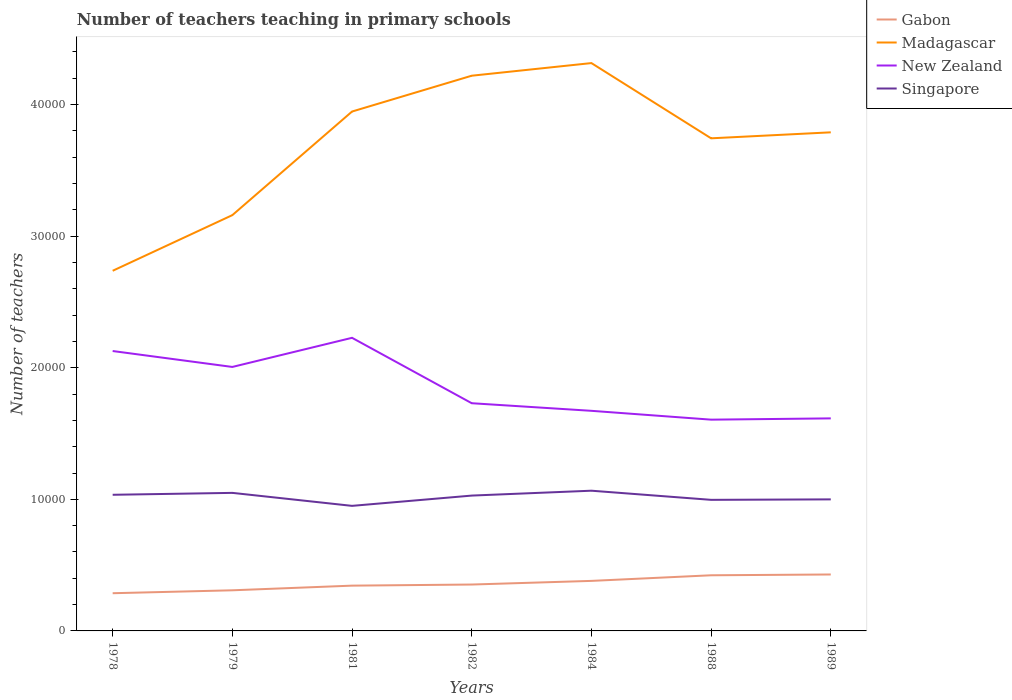Across all years, what is the maximum number of teachers teaching in primary schools in Madagascar?
Offer a very short reply. 2.74e+04. What is the total number of teachers teaching in primary schools in New Zealand in the graph?
Provide a succinct answer. -2214. What is the difference between the highest and the second highest number of teachers teaching in primary schools in Singapore?
Make the answer very short. 1152. What is the difference between the highest and the lowest number of teachers teaching in primary schools in Singapore?
Provide a succinct answer. 4. Is the number of teachers teaching in primary schools in Madagascar strictly greater than the number of teachers teaching in primary schools in New Zealand over the years?
Ensure brevity in your answer.  No. How many years are there in the graph?
Provide a succinct answer. 7. What is the difference between two consecutive major ticks on the Y-axis?
Provide a succinct answer. 10000. Does the graph contain any zero values?
Provide a short and direct response. No. Does the graph contain grids?
Give a very brief answer. No. What is the title of the graph?
Your answer should be very brief. Number of teachers teaching in primary schools. What is the label or title of the Y-axis?
Make the answer very short. Number of teachers. What is the Number of teachers of Gabon in 1978?
Provide a succinct answer. 2866. What is the Number of teachers of Madagascar in 1978?
Make the answer very short. 2.74e+04. What is the Number of teachers in New Zealand in 1978?
Keep it short and to the point. 2.13e+04. What is the Number of teachers of Singapore in 1978?
Give a very brief answer. 1.03e+04. What is the Number of teachers in Gabon in 1979?
Offer a terse response. 3088. What is the Number of teachers of Madagascar in 1979?
Ensure brevity in your answer.  3.16e+04. What is the Number of teachers of New Zealand in 1979?
Offer a very short reply. 2.01e+04. What is the Number of teachers in Singapore in 1979?
Provide a short and direct response. 1.05e+04. What is the Number of teachers in Gabon in 1981?
Provide a succinct answer. 3441. What is the Number of teachers in Madagascar in 1981?
Provide a succinct answer. 3.95e+04. What is the Number of teachers in New Zealand in 1981?
Your answer should be very brief. 2.23e+04. What is the Number of teachers of Singapore in 1981?
Your answer should be compact. 9505. What is the Number of teachers in Gabon in 1982?
Provide a succinct answer. 3526. What is the Number of teachers of Madagascar in 1982?
Make the answer very short. 4.22e+04. What is the Number of teachers in New Zealand in 1982?
Your answer should be compact. 1.73e+04. What is the Number of teachers of Singapore in 1982?
Your answer should be very brief. 1.03e+04. What is the Number of teachers of Gabon in 1984?
Your answer should be very brief. 3802. What is the Number of teachers in Madagascar in 1984?
Give a very brief answer. 4.32e+04. What is the Number of teachers in New Zealand in 1984?
Offer a very short reply. 1.67e+04. What is the Number of teachers in Singapore in 1984?
Provide a succinct answer. 1.07e+04. What is the Number of teachers of Gabon in 1988?
Provide a short and direct response. 4229. What is the Number of teachers in Madagascar in 1988?
Keep it short and to the point. 3.74e+04. What is the Number of teachers of New Zealand in 1988?
Make the answer very short. 1.61e+04. What is the Number of teachers in Singapore in 1988?
Ensure brevity in your answer.  9962. What is the Number of teachers in Gabon in 1989?
Give a very brief answer. 4289. What is the Number of teachers of Madagascar in 1989?
Provide a short and direct response. 3.79e+04. What is the Number of teachers of New Zealand in 1989?
Provide a short and direct response. 1.62e+04. What is the Number of teachers of Singapore in 1989?
Keep it short and to the point. 9998. Across all years, what is the maximum Number of teachers in Gabon?
Your answer should be very brief. 4289. Across all years, what is the maximum Number of teachers in Madagascar?
Provide a succinct answer. 4.32e+04. Across all years, what is the maximum Number of teachers of New Zealand?
Offer a terse response. 2.23e+04. Across all years, what is the maximum Number of teachers of Singapore?
Your response must be concise. 1.07e+04. Across all years, what is the minimum Number of teachers of Gabon?
Make the answer very short. 2866. Across all years, what is the minimum Number of teachers of Madagascar?
Your answer should be very brief. 2.74e+04. Across all years, what is the minimum Number of teachers in New Zealand?
Provide a short and direct response. 1.61e+04. Across all years, what is the minimum Number of teachers of Singapore?
Your answer should be very brief. 9505. What is the total Number of teachers in Gabon in the graph?
Your response must be concise. 2.52e+04. What is the total Number of teachers in Madagascar in the graph?
Make the answer very short. 2.59e+05. What is the total Number of teachers of New Zealand in the graph?
Ensure brevity in your answer.  1.30e+05. What is the total Number of teachers of Singapore in the graph?
Ensure brevity in your answer.  7.12e+04. What is the difference between the Number of teachers in Gabon in 1978 and that in 1979?
Ensure brevity in your answer.  -222. What is the difference between the Number of teachers of Madagascar in 1978 and that in 1979?
Ensure brevity in your answer.  -4230. What is the difference between the Number of teachers in New Zealand in 1978 and that in 1979?
Make the answer very short. 1210. What is the difference between the Number of teachers of Singapore in 1978 and that in 1979?
Ensure brevity in your answer.  -145. What is the difference between the Number of teachers of Gabon in 1978 and that in 1981?
Give a very brief answer. -575. What is the difference between the Number of teachers of Madagascar in 1978 and that in 1981?
Make the answer very short. -1.21e+04. What is the difference between the Number of teachers of New Zealand in 1978 and that in 1981?
Ensure brevity in your answer.  -1004. What is the difference between the Number of teachers in Singapore in 1978 and that in 1981?
Offer a terse response. 842. What is the difference between the Number of teachers of Gabon in 1978 and that in 1982?
Provide a succinct answer. -660. What is the difference between the Number of teachers in Madagascar in 1978 and that in 1982?
Ensure brevity in your answer.  -1.48e+04. What is the difference between the Number of teachers of New Zealand in 1978 and that in 1982?
Keep it short and to the point. 3967. What is the difference between the Number of teachers of Singapore in 1978 and that in 1982?
Your answer should be very brief. 61. What is the difference between the Number of teachers of Gabon in 1978 and that in 1984?
Provide a succinct answer. -936. What is the difference between the Number of teachers in Madagascar in 1978 and that in 1984?
Your answer should be compact. -1.58e+04. What is the difference between the Number of teachers of New Zealand in 1978 and that in 1984?
Your answer should be compact. 4545. What is the difference between the Number of teachers of Singapore in 1978 and that in 1984?
Give a very brief answer. -310. What is the difference between the Number of teachers of Gabon in 1978 and that in 1988?
Keep it short and to the point. -1363. What is the difference between the Number of teachers of Madagascar in 1978 and that in 1988?
Your answer should be very brief. -1.01e+04. What is the difference between the Number of teachers in New Zealand in 1978 and that in 1988?
Provide a short and direct response. 5216. What is the difference between the Number of teachers of Singapore in 1978 and that in 1988?
Your response must be concise. 385. What is the difference between the Number of teachers of Gabon in 1978 and that in 1989?
Your answer should be compact. -1423. What is the difference between the Number of teachers in Madagascar in 1978 and that in 1989?
Your answer should be compact. -1.05e+04. What is the difference between the Number of teachers of New Zealand in 1978 and that in 1989?
Ensure brevity in your answer.  5119. What is the difference between the Number of teachers of Singapore in 1978 and that in 1989?
Your answer should be compact. 349. What is the difference between the Number of teachers in Gabon in 1979 and that in 1981?
Ensure brevity in your answer.  -353. What is the difference between the Number of teachers of Madagascar in 1979 and that in 1981?
Provide a succinct answer. -7873. What is the difference between the Number of teachers of New Zealand in 1979 and that in 1981?
Your answer should be very brief. -2214. What is the difference between the Number of teachers of Singapore in 1979 and that in 1981?
Give a very brief answer. 987. What is the difference between the Number of teachers in Gabon in 1979 and that in 1982?
Your response must be concise. -438. What is the difference between the Number of teachers of Madagascar in 1979 and that in 1982?
Provide a short and direct response. -1.06e+04. What is the difference between the Number of teachers of New Zealand in 1979 and that in 1982?
Your answer should be very brief. 2757. What is the difference between the Number of teachers in Singapore in 1979 and that in 1982?
Make the answer very short. 206. What is the difference between the Number of teachers of Gabon in 1979 and that in 1984?
Provide a short and direct response. -714. What is the difference between the Number of teachers in Madagascar in 1979 and that in 1984?
Provide a short and direct response. -1.16e+04. What is the difference between the Number of teachers in New Zealand in 1979 and that in 1984?
Your answer should be compact. 3335. What is the difference between the Number of teachers of Singapore in 1979 and that in 1984?
Offer a very short reply. -165. What is the difference between the Number of teachers in Gabon in 1979 and that in 1988?
Your answer should be very brief. -1141. What is the difference between the Number of teachers of Madagascar in 1979 and that in 1988?
Keep it short and to the point. -5838. What is the difference between the Number of teachers of New Zealand in 1979 and that in 1988?
Offer a terse response. 4006. What is the difference between the Number of teachers in Singapore in 1979 and that in 1988?
Give a very brief answer. 530. What is the difference between the Number of teachers of Gabon in 1979 and that in 1989?
Provide a succinct answer. -1201. What is the difference between the Number of teachers in Madagascar in 1979 and that in 1989?
Provide a succinct answer. -6293. What is the difference between the Number of teachers of New Zealand in 1979 and that in 1989?
Ensure brevity in your answer.  3909. What is the difference between the Number of teachers in Singapore in 1979 and that in 1989?
Your answer should be very brief. 494. What is the difference between the Number of teachers of Gabon in 1981 and that in 1982?
Give a very brief answer. -85. What is the difference between the Number of teachers in Madagascar in 1981 and that in 1982?
Offer a terse response. -2723. What is the difference between the Number of teachers of New Zealand in 1981 and that in 1982?
Give a very brief answer. 4971. What is the difference between the Number of teachers in Singapore in 1981 and that in 1982?
Give a very brief answer. -781. What is the difference between the Number of teachers of Gabon in 1981 and that in 1984?
Your answer should be compact. -361. What is the difference between the Number of teachers in Madagascar in 1981 and that in 1984?
Make the answer very short. -3683. What is the difference between the Number of teachers in New Zealand in 1981 and that in 1984?
Offer a very short reply. 5549. What is the difference between the Number of teachers in Singapore in 1981 and that in 1984?
Offer a very short reply. -1152. What is the difference between the Number of teachers of Gabon in 1981 and that in 1988?
Keep it short and to the point. -788. What is the difference between the Number of teachers in Madagascar in 1981 and that in 1988?
Your response must be concise. 2035. What is the difference between the Number of teachers of New Zealand in 1981 and that in 1988?
Give a very brief answer. 6220. What is the difference between the Number of teachers in Singapore in 1981 and that in 1988?
Provide a short and direct response. -457. What is the difference between the Number of teachers of Gabon in 1981 and that in 1989?
Your response must be concise. -848. What is the difference between the Number of teachers in Madagascar in 1981 and that in 1989?
Offer a terse response. 1580. What is the difference between the Number of teachers in New Zealand in 1981 and that in 1989?
Your response must be concise. 6123. What is the difference between the Number of teachers in Singapore in 1981 and that in 1989?
Provide a succinct answer. -493. What is the difference between the Number of teachers of Gabon in 1982 and that in 1984?
Ensure brevity in your answer.  -276. What is the difference between the Number of teachers of Madagascar in 1982 and that in 1984?
Make the answer very short. -960. What is the difference between the Number of teachers in New Zealand in 1982 and that in 1984?
Offer a very short reply. 578. What is the difference between the Number of teachers in Singapore in 1982 and that in 1984?
Ensure brevity in your answer.  -371. What is the difference between the Number of teachers of Gabon in 1982 and that in 1988?
Ensure brevity in your answer.  -703. What is the difference between the Number of teachers in Madagascar in 1982 and that in 1988?
Provide a short and direct response. 4758. What is the difference between the Number of teachers in New Zealand in 1982 and that in 1988?
Offer a very short reply. 1249. What is the difference between the Number of teachers in Singapore in 1982 and that in 1988?
Make the answer very short. 324. What is the difference between the Number of teachers in Gabon in 1982 and that in 1989?
Provide a succinct answer. -763. What is the difference between the Number of teachers in Madagascar in 1982 and that in 1989?
Give a very brief answer. 4303. What is the difference between the Number of teachers in New Zealand in 1982 and that in 1989?
Ensure brevity in your answer.  1152. What is the difference between the Number of teachers of Singapore in 1982 and that in 1989?
Ensure brevity in your answer.  288. What is the difference between the Number of teachers in Gabon in 1984 and that in 1988?
Your response must be concise. -427. What is the difference between the Number of teachers in Madagascar in 1984 and that in 1988?
Keep it short and to the point. 5718. What is the difference between the Number of teachers of New Zealand in 1984 and that in 1988?
Your answer should be very brief. 671. What is the difference between the Number of teachers of Singapore in 1984 and that in 1988?
Offer a very short reply. 695. What is the difference between the Number of teachers of Gabon in 1984 and that in 1989?
Ensure brevity in your answer.  -487. What is the difference between the Number of teachers of Madagascar in 1984 and that in 1989?
Provide a short and direct response. 5263. What is the difference between the Number of teachers of New Zealand in 1984 and that in 1989?
Offer a terse response. 574. What is the difference between the Number of teachers in Singapore in 1984 and that in 1989?
Your response must be concise. 659. What is the difference between the Number of teachers in Gabon in 1988 and that in 1989?
Provide a succinct answer. -60. What is the difference between the Number of teachers of Madagascar in 1988 and that in 1989?
Keep it short and to the point. -455. What is the difference between the Number of teachers of New Zealand in 1988 and that in 1989?
Give a very brief answer. -97. What is the difference between the Number of teachers in Singapore in 1988 and that in 1989?
Your answer should be compact. -36. What is the difference between the Number of teachers of Gabon in 1978 and the Number of teachers of Madagascar in 1979?
Offer a very short reply. -2.87e+04. What is the difference between the Number of teachers in Gabon in 1978 and the Number of teachers in New Zealand in 1979?
Give a very brief answer. -1.72e+04. What is the difference between the Number of teachers of Gabon in 1978 and the Number of teachers of Singapore in 1979?
Your answer should be compact. -7626. What is the difference between the Number of teachers of Madagascar in 1978 and the Number of teachers of New Zealand in 1979?
Keep it short and to the point. 7308. What is the difference between the Number of teachers in Madagascar in 1978 and the Number of teachers in Singapore in 1979?
Offer a very short reply. 1.69e+04. What is the difference between the Number of teachers in New Zealand in 1978 and the Number of teachers in Singapore in 1979?
Give a very brief answer. 1.08e+04. What is the difference between the Number of teachers in Gabon in 1978 and the Number of teachers in Madagascar in 1981?
Provide a short and direct response. -3.66e+04. What is the difference between the Number of teachers in Gabon in 1978 and the Number of teachers in New Zealand in 1981?
Ensure brevity in your answer.  -1.94e+04. What is the difference between the Number of teachers in Gabon in 1978 and the Number of teachers in Singapore in 1981?
Give a very brief answer. -6639. What is the difference between the Number of teachers of Madagascar in 1978 and the Number of teachers of New Zealand in 1981?
Your answer should be compact. 5094. What is the difference between the Number of teachers in Madagascar in 1978 and the Number of teachers in Singapore in 1981?
Your answer should be very brief. 1.79e+04. What is the difference between the Number of teachers in New Zealand in 1978 and the Number of teachers in Singapore in 1981?
Your answer should be very brief. 1.18e+04. What is the difference between the Number of teachers in Gabon in 1978 and the Number of teachers in Madagascar in 1982?
Make the answer very short. -3.93e+04. What is the difference between the Number of teachers in Gabon in 1978 and the Number of teachers in New Zealand in 1982?
Your answer should be compact. -1.44e+04. What is the difference between the Number of teachers of Gabon in 1978 and the Number of teachers of Singapore in 1982?
Offer a terse response. -7420. What is the difference between the Number of teachers of Madagascar in 1978 and the Number of teachers of New Zealand in 1982?
Ensure brevity in your answer.  1.01e+04. What is the difference between the Number of teachers of Madagascar in 1978 and the Number of teachers of Singapore in 1982?
Make the answer very short. 1.71e+04. What is the difference between the Number of teachers of New Zealand in 1978 and the Number of teachers of Singapore in 1982?
Provide a succinct answer. 1.10e+04. What is the difference between the Number of teachers of Gabon in 1978 and the Number of teachers of Madagascar in 1984?
Offer a very short reply. -4.03e+04. What is the difference between the Number of teachers of Gabon in 1978 and the Number of teachers of New Zealand in 1984?
Your answer should be compact. -1.39e+04. What is the difference between the Number of teachers in Gabon in 1978 and the Number of teachers in Singapore in 1984?
Offer a terse response. -7791. What is the difference between the Number of teachers in Madagascar in 1978 and the Number of teachers in New Zealand in 1984?
Give a very brief answer. 1.06e+04. What is the difference between the Number of teachers of Madagascar in 1978 and the Number of teachers of Singapore in 1984?
Offer a terse response. 1.67e+04. What is the difference between the Number of teachers in New Zealand in 1978 and the Number of teachers in Singapore in 1984?
Ensure brevity in your answer.  1.06e+04. What is the difference between the Number of teachers of Gabon in 1978 and the Number of teachers of Madagascar in 1988?
Offer a very short reply. -3.46e+04. What is the difference between the Number of teachers of Gabon in 1978 and the Number of teachers of New Zealand in 1988?
Your response must be concise. -1.32e+04. What is the difference between the Number of teachers of Gabon in 1978 and the Number of teachers of Singapore in 1988?
Provide a succinct answer. -7096. What is the difference between the Number of teachers in Madagascar in 1978 and the Number of teachers in New Zealand in 1988?
Make the answer very short. 1.13e+04. What is the difference between the Number of teachers of Madagascar in 1978 and the Number of teachers of Singapore in 1988?
Ensure brevity in your answer.  1.74e+04. What is the difference between the Number of teachers in New Zealand in 1978 and the Number of teachers in Singapore in 1988?
Give a very brief answer. 1.13e+04. What is the difference between the Number of teachers in Gabon in 1978 and the Number of teachers in Madagascar in 1989?
Provide a short and direct response. -3.50e+04. What is the difference between the Number of teachers in Gabon in 1978 and the Number of teachers in New Zealand in 1989?
Your answer should be very brief. -1.33e+04. What is the difference between the Number of teachers in Gabon in 1978 and the Number of teachers in Singapore in 1989?
Ensure brevity in your answer.  -7132. What is the difference between the Number of teachers of Madagascar in 1978 and the Number of teachers of New Zealand in 1989?
Make the answer very short. 1.12e+04. What is the difference between the Number of teachers in Madagascar in 1978 and the Number of teachers in Singapore in 1989?
Your answer should be very brief. 1.74e+04. What is the difference between the Number of teachers in New Zealand in 1978 and the Number of teachers in Singapore in 1989?
Your answer should be very brief. 1.13e+04. What is the difference between the Number of teachers in Gabon in 1979 and the Number of teachers in Madagascar in 1981?
Make the answer very short. -3.64e+04. What is the difference between the Number of teachers in Gabon in 1979 and the Number of teachers in New Zealand in 1981?
Ensure brevity in your answer.  -1.92e+04. What is the difference between the Number of teachers of Gabon in 1979 and the Number of teachers of Singapore in 1981?
Provide a short and direct response. -6417. What is the difference between the Number of teachers of Madagascar in 1979 and the Number of teachers of New Zealand in 1981?
Provide a short and direct response. 9324. What is the difference between the Number of teachers in Madagascar in 1979 and the Number of teachers in Singapore in 1981?
Your answer should be very brief. 2.21e+04. What is the difference between the Number of teachers in New Zealand in 1979 and the Number of teachers in Singapore in 1981?
Ensure brevity in your answer.  1.06e+04. What is the difference between the Number of teachers of Gabon in 1979 and the Number of teachers of Madagascar in 1982?
Offer a very short reply. -3.91e+04. What is the difference between the Number of teachers in Gabon in 1979 and the Number of teachers in New Zealand in 1982?
Make the answer very short. -1.42e+04. What is the difference between the Number of teachers in Gabon in 1979 and the Number of teachers in Singapore in 1982?
Provide a short and direct response. -7198. What is the difference between the Number of teachers of Madagascar in 1979 and the Number of teachers of New Zealand in 1982?
Offer a very short reply. 1.43e+04. What is the difference between the Number of teachers in Madagascar in 1979 and the Number of teachers in Singapore in 1982?
Your answer should be very brief. 2.13e+04. What is the difference between the Number of teachers in New Zealand in 1979 and the Number of teachers in Singapore in 1982?
Make the answer very short. 9777. What is the difference between the Number of teachers of Gabon in 1979 and the Number of teachers of Madagascar in 1984?
Your response must be concise. -4.01e+04. What is the difference between the Number of teachers of Gabon in 1979 and the Number of teachers of New Zealand in 1984?
Keep it short and to the point. -1.36e+04. What is the difference between the Number of teachers in Gabon in 1979 and the Number of teachers in Singapore in 1984?
Provide a succinct answer. -7569. What is the difference between the Number of teachers of Madagascar in 1979 and the Number of teachers of New Zealand in 1984?
Ensure brevity in your answer.  1.49e+04. What is the difference between the Number of teachers of Madagascar in 1979 and the Number of teachers of Singapore in 1984?
Your response must be concise. 2.09e+04. What is the difference between the Number of teachers of New Zealand in 1979 and the Number of teachers of Singapore in 1984?
Your response must be concise. 9406. What is the difference between the Number of teachers of Gabon in 1979 and the Number of teachers of Madagascar in 1988?
Offer a very short reply. -3.44e+04. What is the difference between the Number of teachers in Gabon in 1979 and the Number of teachers in New Zealand in 1988?
Make the answer very short. -1.30e+04. What is the difference between the Number of teachers in Gabon in 1979 and the Number of teachers in Singapore in 1988?
Your response must be concise. -6874. What is the difference between the Number of teachers in Madagascar in 1979 and the Number of teachers in New Zealand in 1988?
Your answer should be very brief. 1.55e+04. What is the difference between the Number of teachers in Madagascar in 1979 and the Number of teachers in Singapore in 1988?
Your answer should be very brief. 2.16e+04. What is the difference between the Number of teachers of New Zealand in 1979 and the Number of teachers of Singapore in 1988?
Give a very brief answer. 1.01e+04. What is the difference between the Number of teachers in Gabon in 1979 and the Number of teachers in Madagascar in 1989?
Offer a very short reply. -3.48e+04. What is the difference between the Number of teachers of Gabon in 1979 and the Number of teachers of New Zealand in 1989?
Your response must be concise. -1.31e+04. What is the difference between the Number of teachers in Gabon in 1979 and the Number of teachers in Singapore in 1989?
Provide a short and direct response. -6910. What is the difference between the Number of teachers in Madagascar in 1979 and the Number of teachers in New Zealand in 1989?
Your answer should be very brief. 1.54e+04. What is the difference between the Number of teachers of Madagascar in 1979 and the Number of teachers of Singapore in 1989?
Your answer should be compact. 2.16e+04. What is the difference between the Number of teachers in New Zealand in 1979 and the Number of teachers in Singapore in 1989?
Your answer should be very brief. 1.01e+04. What is the difference between the Number of teachers in Gabon in 1981 and the Number of teachers in Madagascar in 1982?
Ensure brevity in your answer.  -3.88e+04. What is the difference between the Number of teachers in Gabon in 1981 and the Number of teachers in New Zealand in 1982?
Ensure brevity in your answer.  -1.39e+04. What is the difference between the Number of teachers of Gabon in 1981 and the Number of teachers of Singapore in 1982?
Your answer should be very brief. -6845. What is the difference between the Number of teachers of Madagascar in 1981 and the Number of teachers of New Zealand in 1982?
Your response must be concise. 2.22e+04. What is the difference between the Number of teachers in Madagascar in 1981 and the Number of teachers in Singapore in 1982?
Ensure brevity in your answer.  2.92e+04. What is the difference between the Number of teachers of New Zealand in 1981 and the Number of teachers of Singapore in 1982?
Keep it short and to the point. 1.20e+04. What is the difference between the Number of teachers of Gabon in 1981 and the Number of teachers of Madagascar in 1984?
Provide a succinct answer. -3.97e+04. What is the difference between the Number of teachers of Gabon in 1981 and the Number of teachers of New Zealand in 1984?
Your answer should be compact. -1.33e+04. What is the difference between the Number of teachers of Gabon in 1981 and the Number of teachers of Singapore in 1984?
Provide a short and direct response. -7216. What is the difference between the Number of teachers of Madagascar in 1981 and the Number of teachers of New Zealand in 1984?
Provide a succinct answer. 2.27e+04. What is the difference between the Number of teachers of Madagascar in 1981 and the Number of teachers of Singapore in 1984?
Make the answer very short. 2.88e+04. What is the difference between the Number of teachers of New Zealand in 1981 and the Number of teachers of Singapore in 1984?
Make the answer very short. 1.16e+04. What is the difference between the Number of teachers in Gabon in 1981 and the Number of teachers in Madagascar in 1988?
Offer a terse response. -3.40e+04. What is the difference between the Number of teachers in Gabon in 1981 and the Number of teachers in New Zealand in 1988?
Your answer should be compact. -1.26e+04. What is the difference between the Number of teachers of Gabon in 1981 and the Number of teachers of Singapore in 1988?
Provide a short and direct response. -6521. What is the difference between the Number of teachers of Madagascar in 1981 and the Number of teachers of New Zealand in 1988?
Your answer should be compact. 2.34e+04. What is the difference between the Number of teachers of Madagascar in 1981 and the Number of teachers of Singapore in 1988?
Provide a succinct answer. 2.95e+04. What is the difference between the Number of teachers of New Zealand in 1981 and the Number of teachers of Singapore in 1988?
Your answer should be compact. 1.23e+04. What is the difference between the Number of teachers in Gabon in 1981 and the Number of teachers in Madagascar in 1989?
Provide a succinct answer. -3.45e+04. What is the difference between the Number of teachers in Gabon in 1981 and the Number of teachers in New Zealand in 1989?
Your answer should be compact. -1.27e+04. What is the difference between the Number of teachers in Gabon in 1981 and the Number of teachers in Singapore in 1989?
Provide a short and direct response. -6557. What is the difference between the Number of teachers of Madagascar in 1981 and the Number of teachers of New Zealand in 1989?
Ensure brevity in your answer.  2.33e+04. What is the difference between the Number of teachers in Madagascar in 1981 and the Number of teachers in Singapore in 1989?
Give a very brief answer. 2.95e+04. What is the difference between the Number of teachers in New Zealand in 1981 and the Number of teachers in Singapore in 1989?
Provide a succinct answer. 1.23e+04. What is the difference between the Number of teachers in Gabon in 1982 and the Number of teachers in Madagascar in 1984?
Provide a short and direct response. -3.96e+04. What is the difference between the Number of teachers in Gabon in 1982 and the Number of teachers in New Zealand in 1984?
Your answer should be very brief. -1.32e+04. What is the difference between the Number of teachers in Gabon in 1982 and the Number of teachers in Singapore in 1984?
Offer a very short reply. -7131. What is the difference between the Number of teachers of Madagascar in 1982 and the Number of teachers of New Zealand in 1984?
Your response must be concise. 2.55e+04. What is the difference between the Number of teachers in Madagascar in 1982 and the Number of teachers in Singapore in 1984?
Give a very brief answer. 3.15e+04. What is the difference between the Number of teachers of New Zealand in 1982 and the Number of teachers of Singapore in 1984?
Offer a terse response. 6649. What is the difference between the Number of teachers in Gabon in 1982 and the Number of teachers in Madagascar in 1988?
Keep it short and to the point. -3.39e+04. What is the difference between the Number of teachers in Gabon in 1982 and the Number of teachers in New Zealand in 1988?
Provide a succinct answer. -1.25e+04. What is the difference between the Number of teachers of Gabon in 1982 and the Number of teachers of Singapore in 1988?
Ensure brevity in your answer.  -6436. What is the difference between the Number of teachers of Madagascar in 1982 and the Number of teachers of New Zealand in 1988?
Offer a terse response. 2.61e+04. What is the difference between the Number of teachers in Madagascar in 1982 and the Number of teachers in Singapore in 1988?
Offer a very short reply. 3.22e+04. What is the difference between the Number of teachers in New Zealand in 1982 and the Number of teachers in Singapore in 1988?
Your answer should be very brief. 7344. What is the difference between the Number of teachers of Gabon in 1982 and the Number of teachers of Madagascar in 1989?
Make the answer very short. -3.44e+04. What is the difference between the Number of teachers of Gabon in 1982 and the Number of teachers of New Zealand in 1989?
Your answer should be compact. -1.26e+04. What is the difference between the Number of teachers in Gabon in 1982 and the Number of teachers in Singapore in 1989?
Ensure brevity in your answer.  -6472. What is the difference between the Number of teachers in Madagascar in 1982 and the Number of teachers in New Zealand in 1989?
Your response must be concise. 2.60e+04. What is the difference between the Number of teachers in Madagascar in 1982 and the Number of teachers in Singapore in 1989?
Your answer should be very brief. 3.22e+04. What is the difference between the Number of teachers in New Zealand in 1982 and the Number of teachers in Singapore in 1989?
Give a very brief answer. 7308. What is the difference between the Number of teachers of Gabon in 1984 and the Number of teachers of Madagascar in 1988?
Offer a very short reply. -3.36e+04. What is the difference between the Number of teachers of Gabon in 1984 and the Number of teachers of New Zealand in 1988?
Offer a terse response. -1.23e+04. What is the difference between the Number of teachers in Gabon in 1984 and the Number of teachers in Singapore in 1988?
Ensure brevity in your answer.  -6160. What is the difference between the Number of teachers of Madagascar in 1984 and the Number of teachers of New Zealand in 1988?
Your answer should be very brief. 2.71e+04. What is the difference between the Number of teachers of Madagascar in 1984 and the Number of teachers of Singapore in 1988?
Your answer should be very brief. 3.32e+04. What is the difference between the Number of teachers in New Zealand in 1984 and the Number of teachers in Singapore in 1988?
Provide a succinct answer. 6766. What is the difference between the Number of teachers in Gabon in 1984 and the Number of teachers in Madagascar in 1989?
Provide a succinct answer. -3.41e+04. What is the difference between the Number of teachers of Gabon in 1984 and the Number of teachers of New Zealand in 1989?
Keep it short and to the point. -1.24e+04. What is the difference between the Number of teachers of Gabon in 1984 and the Number of teachers of Singapore in 1989?
Make the answer very short. -6196. What is the difference between the Number of teachers of Madagascar in 1984 and the Number of teachers of New Zealand in 1989?
Your response must be concise. 2.70e+04. What is the difference between the Number of teachers of Madagascar in 1984 and the Number of teachers of Singapore in 1989?
Offer a terse response. 3.32e+04. What is the difference between the Number of teachers in New Zealand in 1984 and the Number of teachers in Singapore in 1989?
Your response must be concise. 6730. What is the difference between the Number of teachers of Gabon in 1988 and the Number of teachers of Madagascar in 1989?
Ensure brevity in your answer.  -3.37e+04. What is the difference between the Number of teachers in Gabon in 1988 and the Number of teachers in New Zealand in 1989?
Ensure brevity in your answer.  -1.19e+04. What is the difference between the Number of teachers in Gabon in 1988 and the Number of teachers in Singapore in 1989?
Keep it short and to the point. -5769. What is the difference between the Number of teachers of Madagascar in 1988 and the Number of teachers of New Zealand in 1989?
Ensure brevity in your answer.  2.13e+04. What is the difference between the Number of teachers in Madagascar in 1988 and the Number of teachers in Singapore in 1989?
Make the answer very short. 2.74e+04. What is the difference between the Number of teachers in New Zealand in 1988 and the Number of teachers in Singapore in 1989?
Your answer should be compact. 6059. What is the average Number of teachers in Gabon per year?
Make the answer very short. 3605.86. What is the average Number of teachers in Madagascar per year?
Keep it short and to the point. 3.70e+04. What is the average Number of teachers of New Zealand per year?
Your response must be concise. 1.86e+04. What is the average Number of teachers in Singapore per year?
Your response must be concise. 1.02e+04. In the year 1978, what is the difference between the Number of teachers in Gabon and Number of teachers in Madagascar?
Your answer should be compact. -2.45e+04. In the year 1978, what is the difference between the Number of teachers of Gabon and Number of teachers of New Zealand?
Your answer should be compact. -1.84e+04. In the year 1978, what is the difference between the Number of teachers in Gabon and Number of teachers in Singapore?
Offer a very short reply. -7481. In the year 1978, what is the difference between the Number of teachers of Madagascar and Number of teachers of New Zealand?
Provide a succinct answer. 6098. In the year 1978, what is the difference between the Number of teachers in Madagascar and Number of teachers in Singapore?
Offer a terse response. 1.70e+04. In the year 1978, what is the difference between the Number of teachers in New Zealand and Number of teachers in Singapore?
Keep it short and to the point. 1.09e+04. In the year 1979, what is the difference between the Number of teachers of Gabon and Number of teachers of Madagascar?
Ensure brevity in your answer.  -2.85e+04. In the year 1979, what is the difference between the Number of teachers in Gabon and Number of teachers in New Zealand?
Your answer should be very brief. -1.70e+04. In the year 1979, what is the difference between the Number of teachers in Gabon and Number of teachers in Singapore?
Provide a short and direct response. -7404. In the year 1979, what is the difference between the Number of teachers in Madagascar and Number of teachers in New Zealand?
Keep it short and to the point. 1.15e+04. In the year 1979, what is the difference between the Number of teachers of Madagascar and Number of teachers of Singapore?
Your answer should be compact. 2.11e+04. In the year 1979, what is the difference between the Number of teachers of New Zealand and Number of teachers of Singapore?
Your response must be concise. 9571. In the year 1981, what is the difference between the Number of teachers in Gabon and Number of teachers in Madagascar?
Your response must be concise. -3.60e+04. In the year 1981, what is the difference between the Number of teachers of Gabon and Number of teachers of New Zealand?
Offer a very short reply. -1.88e+04. In the year 1981, what is the difference between the Number of teachers of Gabon and Number of teachers of Singapore?
Your answer should be compact. -6064. In the year 1981, what is the difference between the Number of teachers in Madagascar and Number of teachers in New Zealand?
Offer a very short reply. 1.72e+04. In the year 1981, what is the difference between the Number of teachers of Madagascar and Number of teachers of Singapore?
Offer a terse response. 3.00e+04. In the year 1981, what is the difference between the Number of teachers in New Zealand and Number of teachers in Singapore?
Ensure brevity in your answer.  1.28e+04. In the year 1982, what is the difference between the Number of teachers of Gabon and Number of teachers of Madagascar?
Provide a short and direct response. -3.87e+04. In the year 1982, what is the difference between the Number of teachers of Gabon and Number of teachers of New Zealand?
Offer a terse response. -1.38e+04. In the year 1982, what is the difference between the Number of teachers of Gabon and Number of teachers of Singapore?
Offer a terse response. -6760. In the year 1982, what is the difference between the Number of teachers of Madagascar and Number of teachers of New Zealand?
Provide a short and direct response. 2.49e+04. In the year 1982, what is the difference between the Number of teachers of Madagascar and Number of teachers of Singapore?
Ensure brevity in your answer.  3.19e+04. In the year 1982, what is the difference between the Number of teachers of New Zealand and Number of teachers of Singapore?
Make the answer very short. 7020. In the year 1984, what is the difference between the Number of teachers in Gabon and Number of teachers in Madagascar?
Offer a terse response. -3.94e+04. In the year 1984, what is the difference between the Number of teachers of Gabon and Number of teachers of New Zealand?
Provide a succinct answer. -1.29e+04. In the year 1984, what is the difference between the Number of teachers of Gabon and Number of teachers of Singapore?
Keep it short and to the point. -6855. In the year 1984, what is the difference between the Number of teachers of Madagascar and Number of teachers of New Zealand?
Offer a terse response. 2.64e+04. In the year 1984, what is the difference between the Number of teachers of Madagascar and Number of teachers of Singapore?
Offer a terse response. 3.25e+04. In the year 1984, what is the difference between the Number of teachers of New Zealand and Number of teachers of Singapore?
Give a very brief answer. 6071. In the year 1988, what is the difference between the Number of teachers of Gabon and Number of teachers of Madagascar?
Offer a terse response. -3.32e+04. In the year 1988, what is the difference between the Number of teachers in Gabon and Number of teachers in New Zealand?
Provide a short and direct response. -1.18e+04. In the year 1988, what is the difference between the Number of teachers in Gabon and Number of teachers in Singapore?
Keep it short and to the point. -5733. In the year 1988, what is the difference between the Number of teachers in Madagascar and Number of teachers in New Zealand?
Make the answer very short. 2.14e+04. In the year 1988, what is the difference between the Number of teachers in Madagascar and Number of teachers in Singapore?
Ensure brevity in your answer.  2.75e+04. In the year 1988, what is the difference between the Number of teachers of New Zealand and Number of teachers of Singapore?
Your response must be concise. 6095. In the year 1989, what is the difference between the Number of teachers in Gabon and Number of teachers in Madagascar?
Your answer should be compact. -3.36e+04. In the year 1989, what is the difference between the Number of teachers of Gabon and Number of teachers of New Zealand?
Keep it short and to the point. -1.19e+04. In the year 1989, what is the difference between the Number of teachers of Gabon and Number of teachers of Singapore?
Your answer should be very brief. -5709. In the year 1989, what is the difference between the Number of teachers in Madagascar and Number of teachers in New Zealand?
Your response must be concise. 2.17e+04. In the year 1989, what is the difference between the Number of teachers in Madagascar and Number of teachers in Singapore?
Offer a very short reply. 2.79e+04. In the year 1989, what is the difference between the Number of teachers of New Zealand and Number of teachers of Singapore?
Ensure brevity in your answer.  6156. What is the ratio of the Number of teachers of Gabon in 1978 to that in 1979?
Ensure brevity in your answer.  0.93. What is the ratio of the Number of teachers of Madagascar in 1978 to that in 1979?
Your answer should be compact. 0.87. What is the ratio of the Number of teachers in New Zealand in 1978 to that in 1979?
Ensure brevity in your answer.  1.06. What is the ratio of the Number of teachers of Singapore in 1978 to that in 1979?
Ensure brevity in your answer.  0.99. What is the ratio of the Number of teachers of Gabon in 1978 to that in 1981?
Ensure brevity in your answer.  0.83. What is the ratio of the Number of teachers of Madagascar in 1978 to that in 1981?
Your answer should be very brief. 0.69. What is the ratio of the Number of teachers in New Zealand in 1978 to that in 1981?
Ensure brevity in your answer.  0.95. What is the ratio of the Number of teachers of Singapore in 1978 to that in 1981?
Your response must be concise. 1.09. What is the ratio of the Number of teachers in Gabon in 1978 to that in 1982?
Keep it short and to the point. 0.81. What is the ratio of the Number of teachers of Madagascar in 1978 to that in 1982?
Your response must be concise. 0.65. What is the ratio of the Number of teachers in New Zealand in 1978 to that in 1982?
Offer a terse response. 1.23. What is the ratio of the Number of teachers of Singapore in 1978 to that in 1982?
Provide a succinct answer. 1.01. What is the ratio of the Number of teachers of Gabon in 1978 to that in 1984?
Keep it short and to the point. 0.75. What is the ratio of the Number of teachers of Madagascar in 1978 to that in 1984?
Make the answer very short. 0.63. What is the ratio of the Number of teachers of New Zealand in 1978 to that in 1984?
Give a very brief answer. 1.27. What is the ratio of the Number of teachers in Singapore in 1978 to that in 1984?
Give a very brief answer. 0.97. What is the ratio of the Number of teachers in Gabon in 1978 to that in 1988?
Keep it short and to the point. 0.68. What is the ratio of the Number of teachers of Madagascar in 1978 to that in 1988?
Offer a very short reply. 0.73. What is the ratio of the Number of teachers of New Zealand in 1978 to that in 1988?
Make the answer very short. 1.32. What is the ratio of the Number of teachers in Singapore in 1978 to that in 1988?
Provide a short and direct response. 1.04. What is the ratio of the Number of teachers in Gabon in 1978 to that in 1989?
Provide a short and direct response. 0.67. What is the ratio of the Number of teachers of Madagascar in 1978 to that in 1989?
Keep it short and to the point. 0.72. What is the ratio of the Number of teachers in New Zealand in 1978 to that in 1989?
Offer a terse response. 1.32. What is the ratio of the Number of teachers of Singapore in 1978 to that in 1989?
Your answer should be very brief. 1.03. What is the ratio of the Number of teachers of Gabon in 1979 to that in 1981?
Keep it short and to the point. 0.9. What is the ratio of the Number of teachers of Madagascar in 1979 to that in 1981?
Offer a terse response. 0.8. What is the ratio of the Number of teachers in New Zealand in 1979 to that in 1981?
Offer a terse response. 0.9. What is the ratio of the Number of teachers of Singapore in 1979 to that in 1981?
Give a very brief answer. 1.1. What is the ratio of the Number of teachers in Gabon in 1979 to that in 1982?
Provide a short and direct response. 0.88. What is the ratio of the Number of teachers in Madagascar in 1979 to that in 1982?
Your response must be concise. 0.75. What is the ratio of the Number of teachers of New Zealand in 1979 to that in 1982?
Keep it short and to the point. 1.16. What is the ratio of the Number of teachers in Gabon in 1979 to that in 1984?
Offer a very short reply. 0.81. What is the ratio of the Number of teachers in Madagascar in 1979 to that in 1984?
Ensure brevity in your answer.  0.73. What is the ratio of the Number of teachers in New Zealand in 1979 to that in 1984?
Your answer should be very brief. 1.2. What is the ratio of the Number of teachers of Singapore in 1979 to that in 1984?
Your answer should be compact. 0.98. What is the ratio of the Number of teachers of Gabon in 1979 to that in 1988?
Offer a terse response. 0.73. What is the ratio of the Number of teachers in Madagascar in 1979 to that in 1988?
Provide a short and direct response. 0.84. What is the ratio of the Number of teachers of New Zealand in 1979 to that in 1988?
Give a very brief answer. 1.25. What is the ratio of the Number of teachers of Singapore in 1979 to that in 1988?
Ensure brevity in your answer.  1.05. What is the ratio of the Number of teachers of Gabon in 1979 to that in 1989?
Provide a short and direct response. 0.72. What is the ratio of the Number of teachers of Madagascar in 1979 to that in 1989?
Your response must be concise. 0.83. What is the ratio of the Number of teachers of New Zealand in 1979 to that in 1989?
Your answer should be compact. 1.24. What is the ratio of the Number of teachers in Singapore in 1979 to that in 1989?
Your answer should be very brief. 1.05. What is the ratio of the Number of teachers in Gabon in 1981 to that in 1982?
Give a very brief answer. 0.98. What is the ratio of the Number of teachers of Madagascar in 1981 to that in 1982?
Your response must be concise. 0.94. What is the ratio of the Number of teachers of New Zealand in 1981 to that in 1982?
Make the answer very short. 1.29. What is the ratio of the Number of teachers of Singapore in 1981 to that in 1982?
Your answer should be very brief. 0.92. What is the ratio of the Number of teachers in Gabon in 1981 to that in 1984?
Your answer should be very brief. 0.91. What is the ratio of the Number of teachers in Madagascar in 1981 to that in 1984?
Your answer should be very brief. 0.91. What is the ratio of the Number of teachers in New Zealand in 1981 to that in 1984?
Offer a very short reply. 1.33. What is the ratio of the Number of teachers in Singapore in 1981 to that in 1984?
Your answer should be compact. 0.89. What is the ratio of the Number of teachers of Gabon in 1981 to that in 1988?
Provide a succinct answer. 0.81. What is the ratio of the Number of teachers of Madagascar in 1981 to that in 1988?
Your answer should be compact. 1.05. What is the ratio of the Number of teachers in New Zealand in 1981 to that in 1988?
Give a very brief answer. 1.39. What is the ratio of the Number of teachers of Singapore in 1981 to that in 1988?
Offer a very short reply. 0.95. What is the ratio of the Number of teachers in Gabon in 1981 to that in 1989?
Provide a short and direct response. 0.8. What is the ratio of the Number of teachers in Madagascar in 1981 to that in 1989?
Provide a short and direct response. 1.04. What is the ratio of the Number of teachers of New Zealand in 1981 to that in 1989?
Your response must be concise. 1.38. What is the ratio of the Number of teachers in Singapore in 1981 to that in 1989?
Your answer should be compact. 0.95. What is the ratio of the Number of teachers in Gabon in 1982 to that in 1984?
Offer a very short reply. 0.93. What is the ratio of the Number of teachers in Madagascar in 1982 to that in 1984?
Keep it short and to the point. 0.98. What is the ratio of the Number of teachers in New Zealand in 1982 to that in 1984?
Make the answer very short. 1.03. What is the ratio of the Number of teachers of Singapore in 1982 to that in 1984?
Ensure brevity in your answer.  0.97. What is the ratio of the Number of teachers in Gabon in 1982 to that in 1988?
Ensure brevity in your answer.  0.83. What is the ratio of the Number of teachers of Madagascar in 1982 to that in 1988?
Your answer should be very brief. 1.13. What is the ratio of the Number of teachers of New Zealand in 1982 to that in 1988?
Provide a succinct answer. 1.08. What is the ratio of the Number of teachers in Singapore in 1982 to that in 1988?
Keep it short and to the point. 1.03. What is the ratio of the Number of teachers of Gabon in 1982 to that in 1989?
Give a very brief answer. 0.82. What is the ratio of the Number of teachers in Madagascar in 1982 to that in 1989?
Offer a very short reply. 1.11. What is the ratio of the Number of teachers of New Zealand in 1982 to that in 1989?
Your answer should be very brief. 1.07. What is the ratio of the Number of teachers in Singapore in 1982 to that in 1989?
Offer a very short reply. 1.03. What is the ratio of the Number of teachers of Gabon in 1984 to that in 1988?
Offer a very short reply. 0.9. What is the ratio of the Number of teachers of Madagascar in 1984 to that in 1988?
Offer a very short reply. 1.15. What is the ratio of the Number of teachers in New Zealand in 1984 to that in 1988?
Give a very brief answer. 1.04. What is the ratio of the Number of teachers of Singapore in 1984 to that in 1988?
Your response must be concise. 1.07. What is the ratio of the Number of teachers of Gabon in 1984 to that in 1989?
Your response must be concise. 0.89. What is the ratio of the Number of teachers in Madagascar in 1984 to that in 1989?
Offer a terse response. 1.14. What is the ratio of the Number of teachers of New Zealand in 1984 to that in 1989?
Keep it short and to the point. 1.04. What is the ratio of the Number of teachers in Singapore in 1984 to that in 1989?
Ensure brevity in your answer.  1.07. What is the ratio of the Number of teachers of Madagascar in 1988 to that in 1989?
Your answer should be very brief. 0.99. What is the difference between the highest and the second highest Number of teachers of Gabon?
Your answer should be compact. 60. What is the difference between the highest and the second highest Number of teachers in Madagascar?
Offer a terse response. 960. What is the difference between the highest and the second highest Number of teachers in New Zealand?
Your answer should be very brief. 1004. What is the difference between the highest and the second highest Number of teachers in Singapore?
Give a very brief answer. 165. What is the difference between the highest and the lowest Number of teachers of Gabon?
Your answer should be very brief. 1423. What is the difference between the highest and the lowest Number of teachers in Madagascar?
Your answer should be compact. 1.58e+04. What is the difference between the highest and the lowest Number of teachers of New Zealand?
Make the answer very short. 6220. What is the difference between the highest and the lowest Number of teachers in Singapore?
Provide a short and direct response. 1152. 